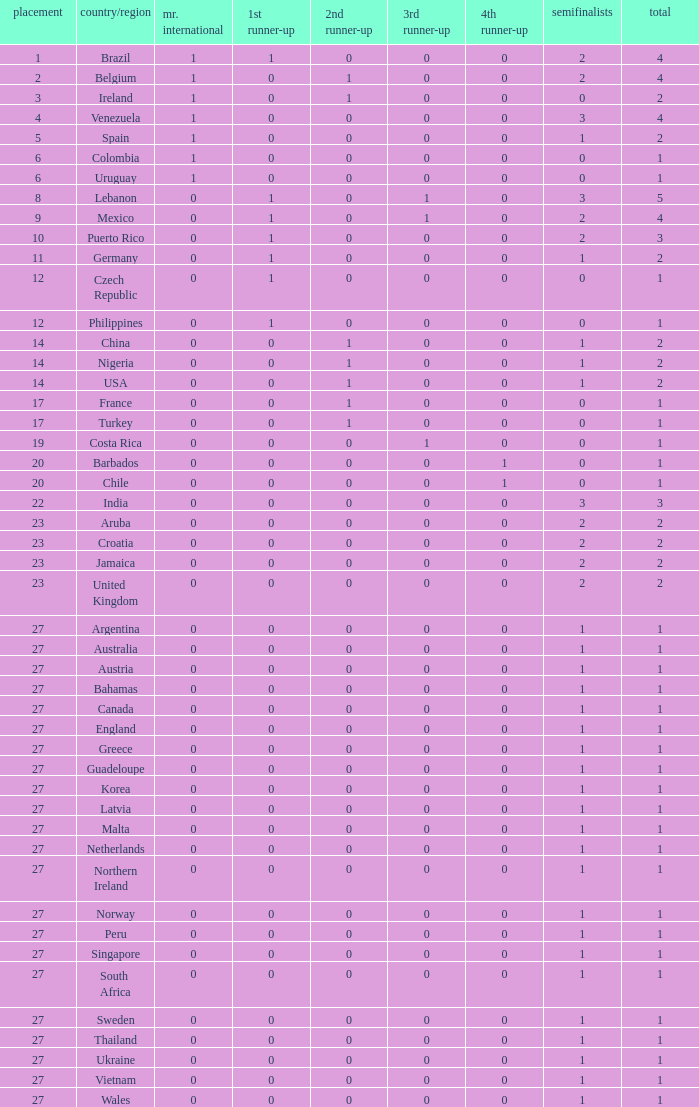How many 3rd runner up values does Turkey have? 1.0. 